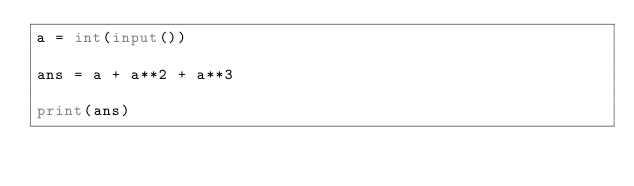Convert code to text. <code><loc_0><loc_0><loc_500><loc_500><_Python_>a = int(input())

ans = a + a**2 + a**3

print(ans)</code> 